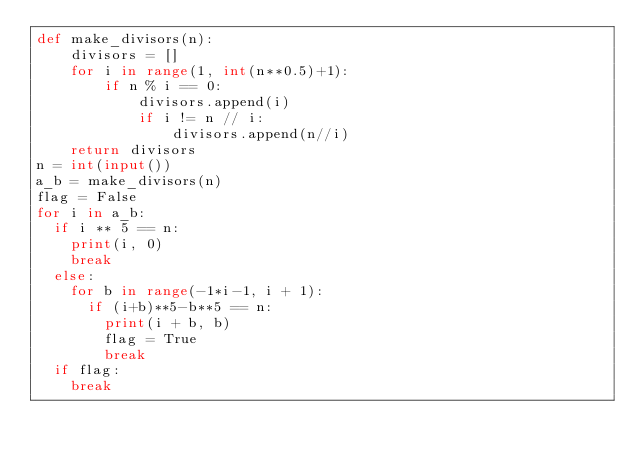Convert code to text. <code><loc_0><loc_0><loc_500><loc_500><_Python_>def make_divisors(n):
    divisors = []
    for i in range(1, int(n**0.5)+1):
        if n % i == 0:
            divisors.append(i)
            if i != n // i:
                divisors.append(n//i)
    return divisors
n = int(input())
a_b = make_divisors(n)
flag = False
for i in a_b:
  if i ** 5 == n:
    print(i, 0)
    break
  else:
    for b in range(-1*i-1, i + 1):
      if (i+b)**5-b**5 == n:
        print(i + b, b)
        flag = True
        break
  if flag:
    break</code> 